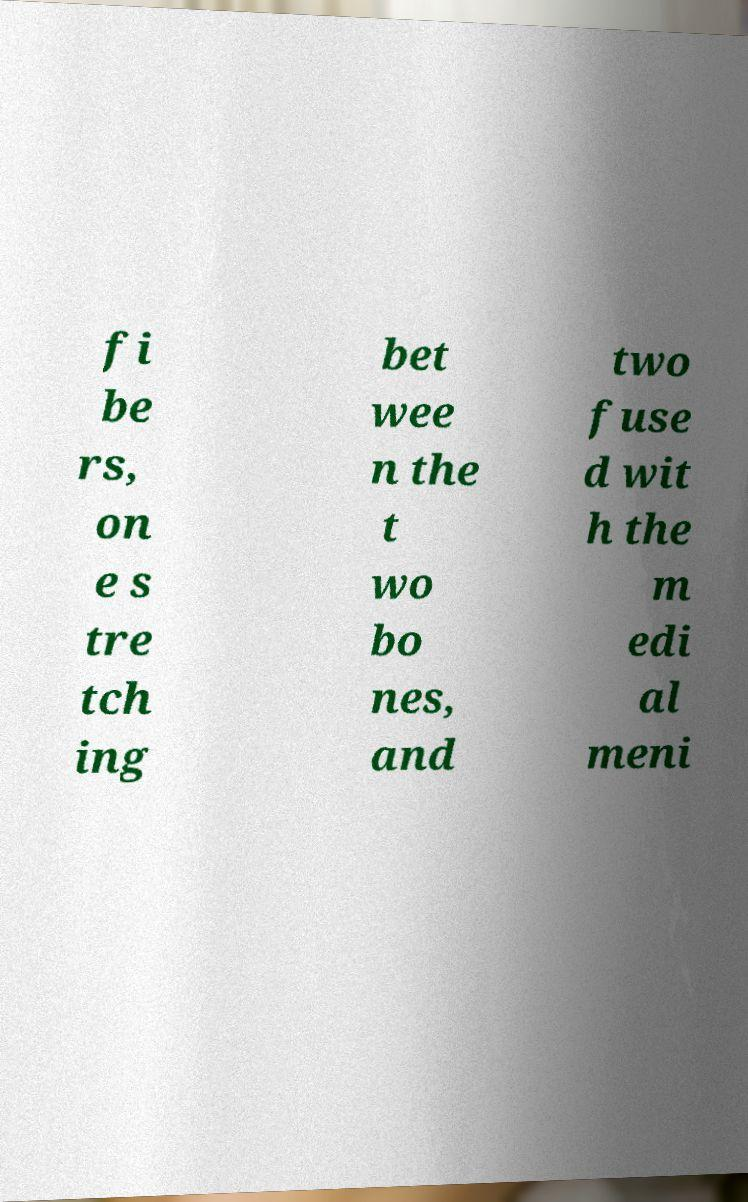There's text embedded in this image that I need extracted. Can you transcribe it verbatim? fi be rs, on e s tre tch ing bet wee n the t wo bo nes, and two fuse d wit h the m edi al meni 